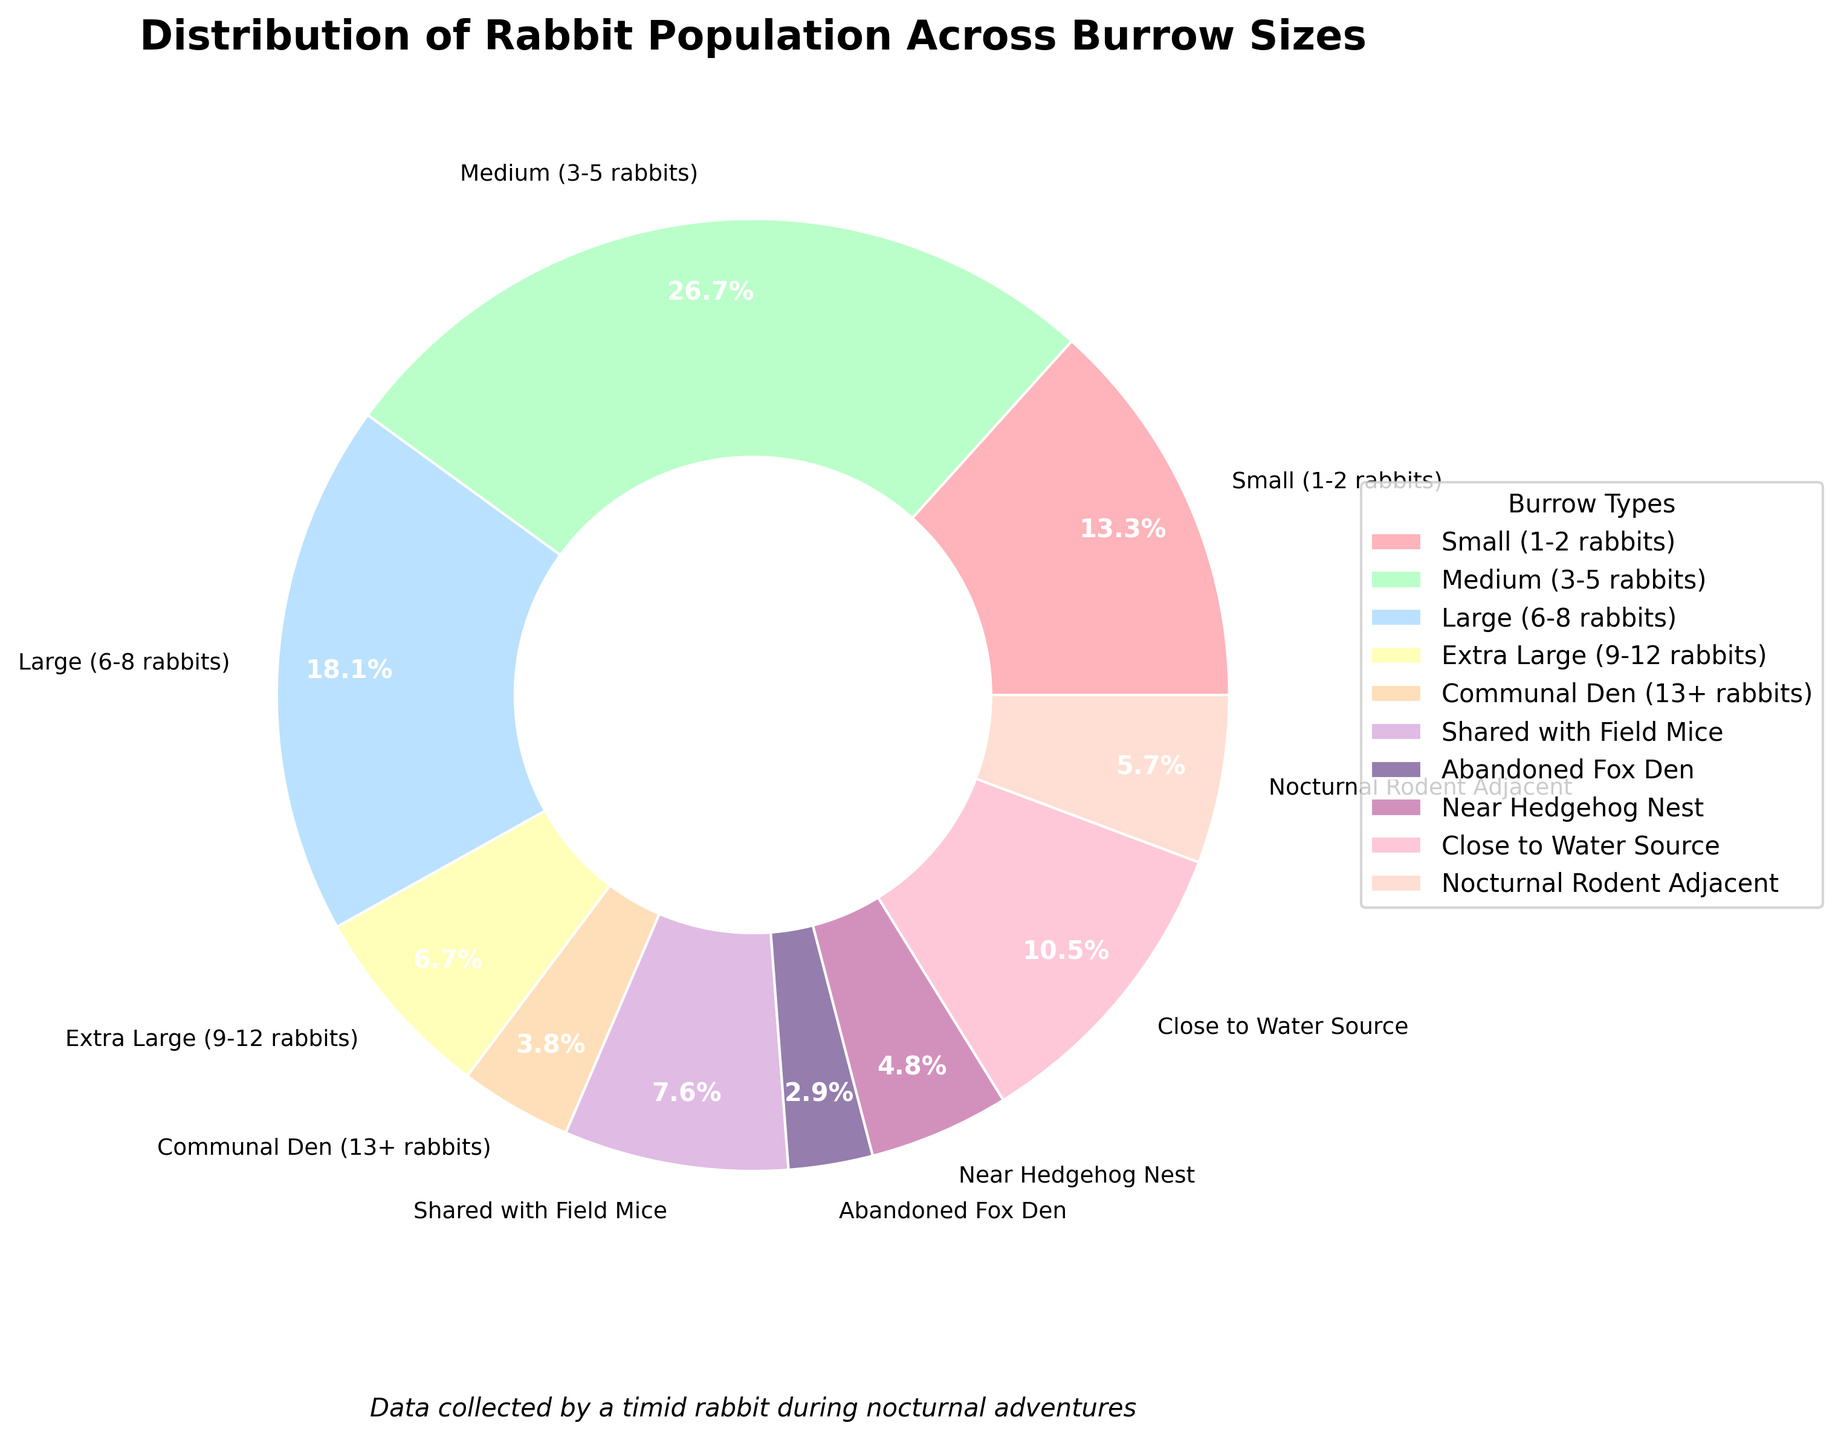What burrow size has the highest percentage of rabbits? The segment with the highest percentage can be identified by looking at the largest slice of the pie chart. The "Medium (3-5 rabbits)" category appears to have the largest slice.
Answer: Medium (3-5 rabbits) How many rabbits live in shared spaces with other animals? To find the total number of rabbits in shared spaces, sum the numbers in "Shared with Field Mice", "Near Hedgehog Nest", and "Nocturnal Rodent Adjacent". This is 8 + 5 + 6.
Answer: 19 Which two burrow sizes have the smallest population of rabbits? Look for the smallest slices in the pie chart. The "Abandoned Fox Den" and "Communal Den (13+ rabbits)" categories both appear quite small.
Answer: Abandoned Fox Den, Communal Den (13+ rabbits) Is the number of rabbits living in a medium-sized burrow greater than the total number of rabbits in both extra large and communal dens combined? Compare the number in "Medium (3-5 rabbits)" against the sum of "Extra Large (9–12 rabbits)" and "Communal Den (13+ rabbits)." Medium has 28 rabbits, and Extra Large plus Communal Den is 7 + 4 = 11.
Answer: Yes What percentage of rabbits live in burrows adjacent to nocturnal rodents? Refer to the slice labeled "Nocturnal Rodent Adjacent" and find its percentage annotation. It is marked as approximately 5.4%.
Answer: 5.4% What is the combined total of rabbits living in large, extra-large, and shared spaces with field mice? Add the numbers of rabbits in "Large (6-8 rabbits)", "Extra Large (9-12 rabbits)", and "Shared with Field Mice". This is 19 + 7 + 8.
Answer: 34 Do more rabbits live close to a water source than in small burrows? Compare the slices labeled "Close to Water Source" and "Small (1-2 rabbits)". The "Close to Water Source" has 11 rabbits, while the "Small (1-2 rabbits)" has 14 rabbits.
Answer: No What color represents the rabbits living near a hedgehog nest? Identify the color of the slice labeled "Near Hedgehog Nest". It is a purple shade.
Answer: Purple Comparing medium-sized burrows and large burrows, which has a higher number and what is the difference? Compare the numbers in "Medium (3-5 rabbits)" and "Large (6-8 rabbits)". Medium has 28 rabbits, and Large has 19 rabbits. The difference is 28 - 19 = 9.
Answer: Medium, 9 What is the total number of rabbits in small and nocturnal rodent-adjacent burrows combined? Sum the number of rabbits in the "Small (1-2 rabbits)" and "Nocturnal Rodent Adjacent" categories. This is 14 + 6.
Answer: 20 